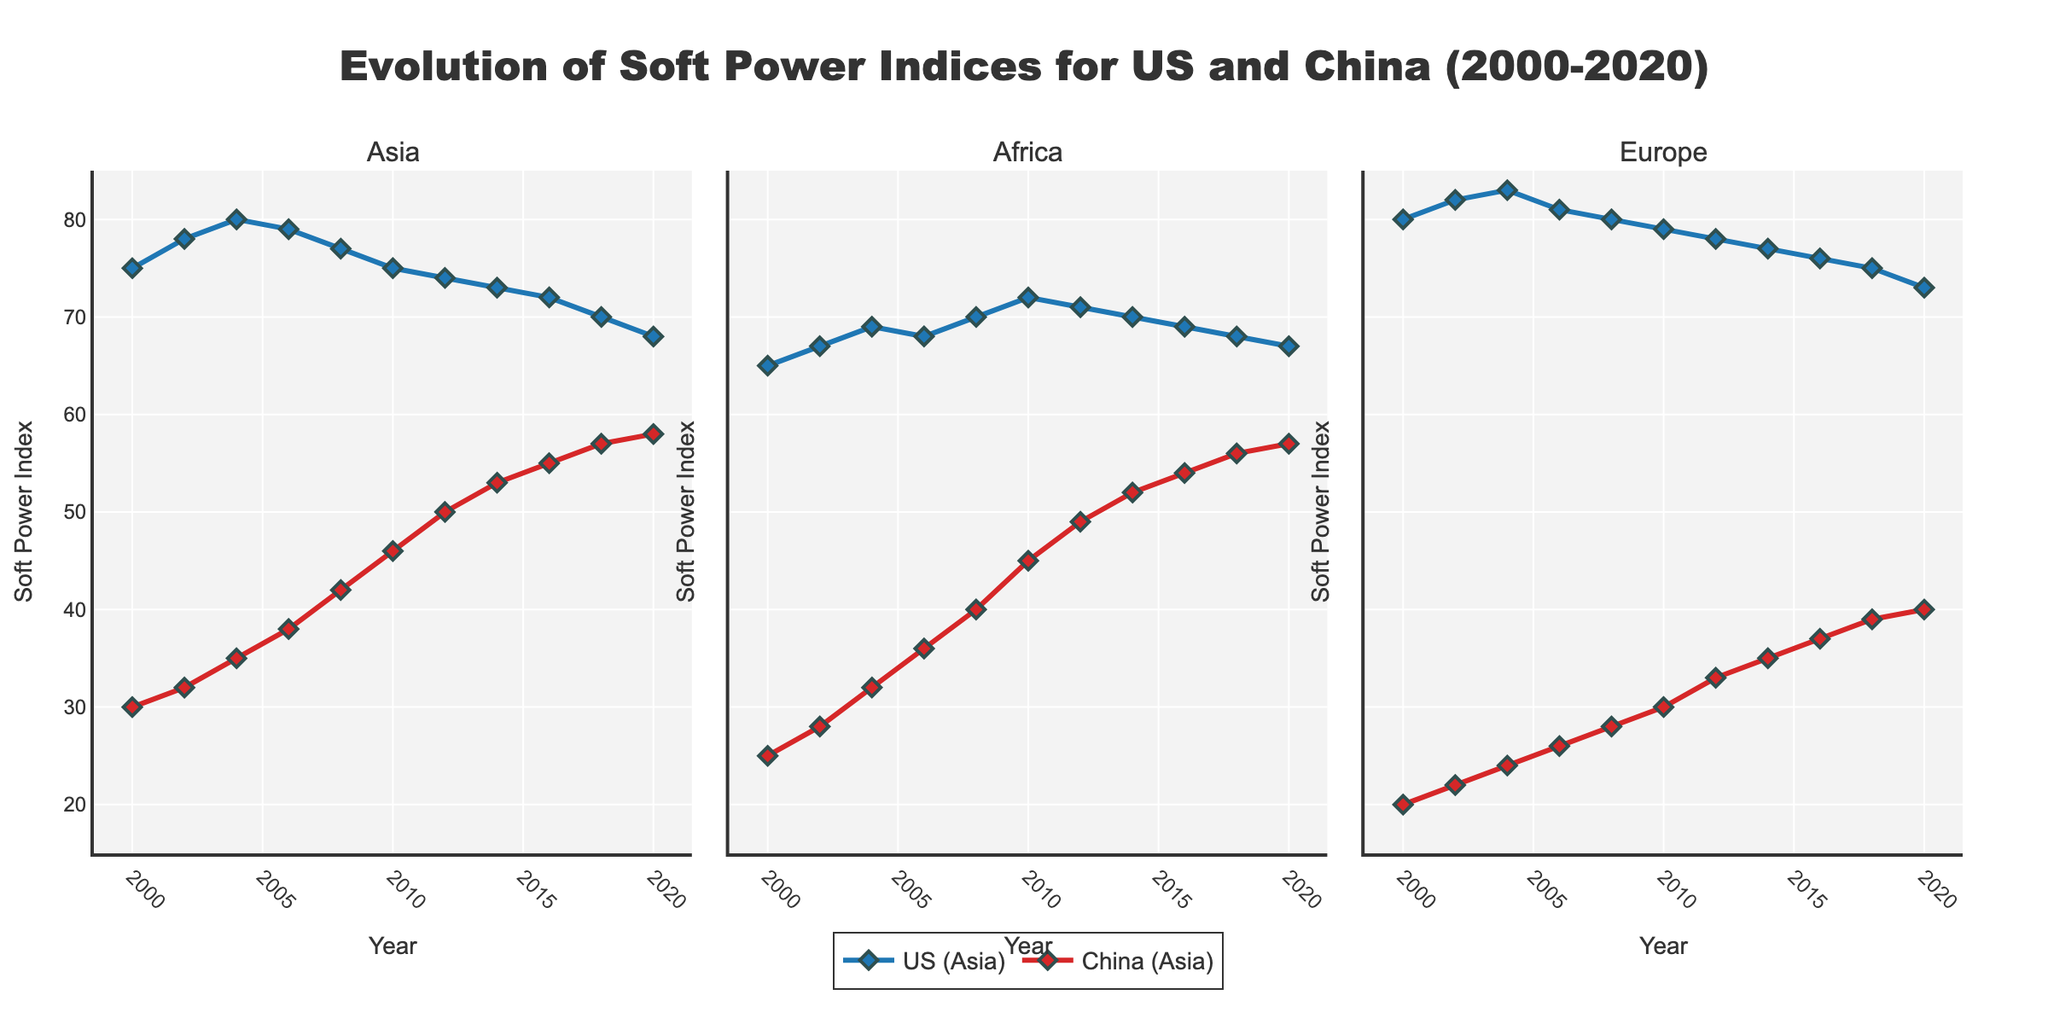Which country showed consistent growth in soft power across all regions from 2000 to 2020? To determine this, examine the trend lines for both the US and China in each subplot. The US shows a declining or fluctuating trend, whereas China exhibits a consistent upward trend in all regions.
Answer: China By how much did China's soft power index in Asia increase from 2000 to 2020? First, locate the data points for China in Asia for the years 2000 (30) and 2020 (58). Calculate the difference using 58 - 30.
Answer: 28 During which year did the US soft power index in Europe reach its highest point? Check the plot for Europe and identify the year with the highest data point for the US. This occurs in 2004, where the index reaches 83.
Answer: 2004 Compare the soft power indices of the US and China in Africa for the year 2010. Which country was higher, and by how much? Locate the 2010 data points for Africa: the US is at 72, and China is at 45. The difference is calculated as 72 - 45.
Answer: US was higher by 27 What was the average soft power index of China across all regions in the year 2012? First, identify the soft power indices for China in 2012: Asia (50), Africa (49), and Europe (33). Calculate the average: (50 + 49 + 33) / 3.
Answer: 44 How many times did the US soft power index in Asia decline from one measurement to the next between 2000 and 2020? Examine the data points for the US in Asia between 2000 (75) and 2020 (68). The indices decline from 2006 to 2008, from 2008 to 2010, and from 2018 to 2020. Thus, it declines 3 times.
Answer: 3 Which region showed the smallest gap between the US and China's soft power indices in 2020? Compare the differences between the US and China's indices in 2020 for all regions: Asia (68 vs 58, gap = 10), Africa (67 vs 57, gap = 10), Europe (73 vs 40, gap = 33). The smallest gap is 10, found in both Asia and Africa.
Answer: Asia and Africa Is there any region where China's soft power index overtook the US's between 2000 and 2020? If yes, which year and region? Identify where China's index surpasses the US in a specific region over the timeline. In Africa, China's index exceeds the US's in 2020.
Answer: Africa, 2020 